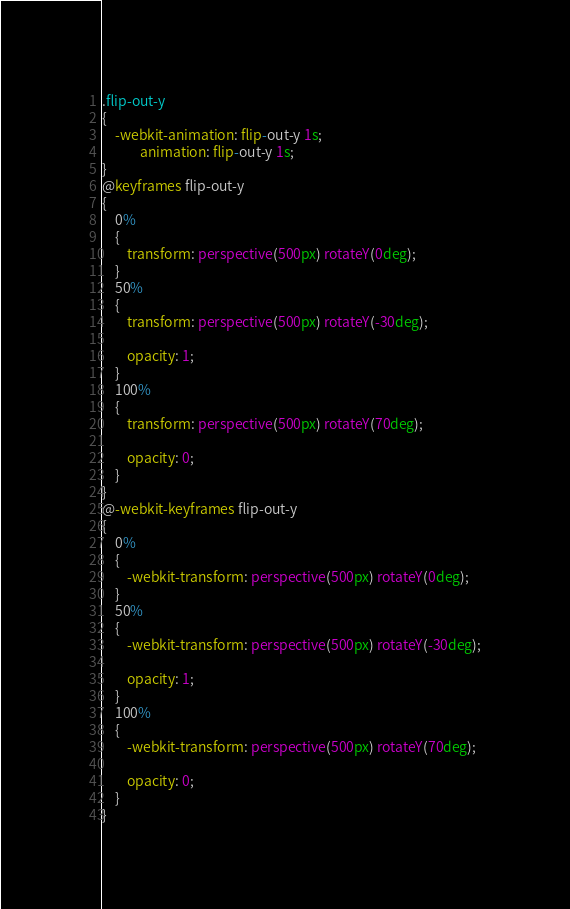Convert code to text. <code><loc_0><loc_0><loc_500><loc_500><_CSS_>.flip-out-y
{
    -webkit-animation: flip-out-y 1s;
            animation: flip-out-y 1s;
}
@keyframes flip-out-y
{
    0%
    {
        transform: perspective(500px) rotateY(0deg);
    }
    50%
    {
        transform: perspective(500px) rotateY(-30deg);

        opacity: 1;
    }
    100%
    {
        transform: perspective(500px) rotateY(70deg);

        opacity: 0;
    }
}
@-webkit-keyframes flip-out-y
{
    0%
    {
        -webkit-transform: perspective(500px) rotateY(0deg);
    }
    50%
    {
        -webkit-transform: perspective(500px) rotateY(-30deg);

        opacity: 1;
    }
    100%
    {
        -webkit-transform: perspective(500px) rotateY(70deg);

        opacity: 0;
    }
}</code> 